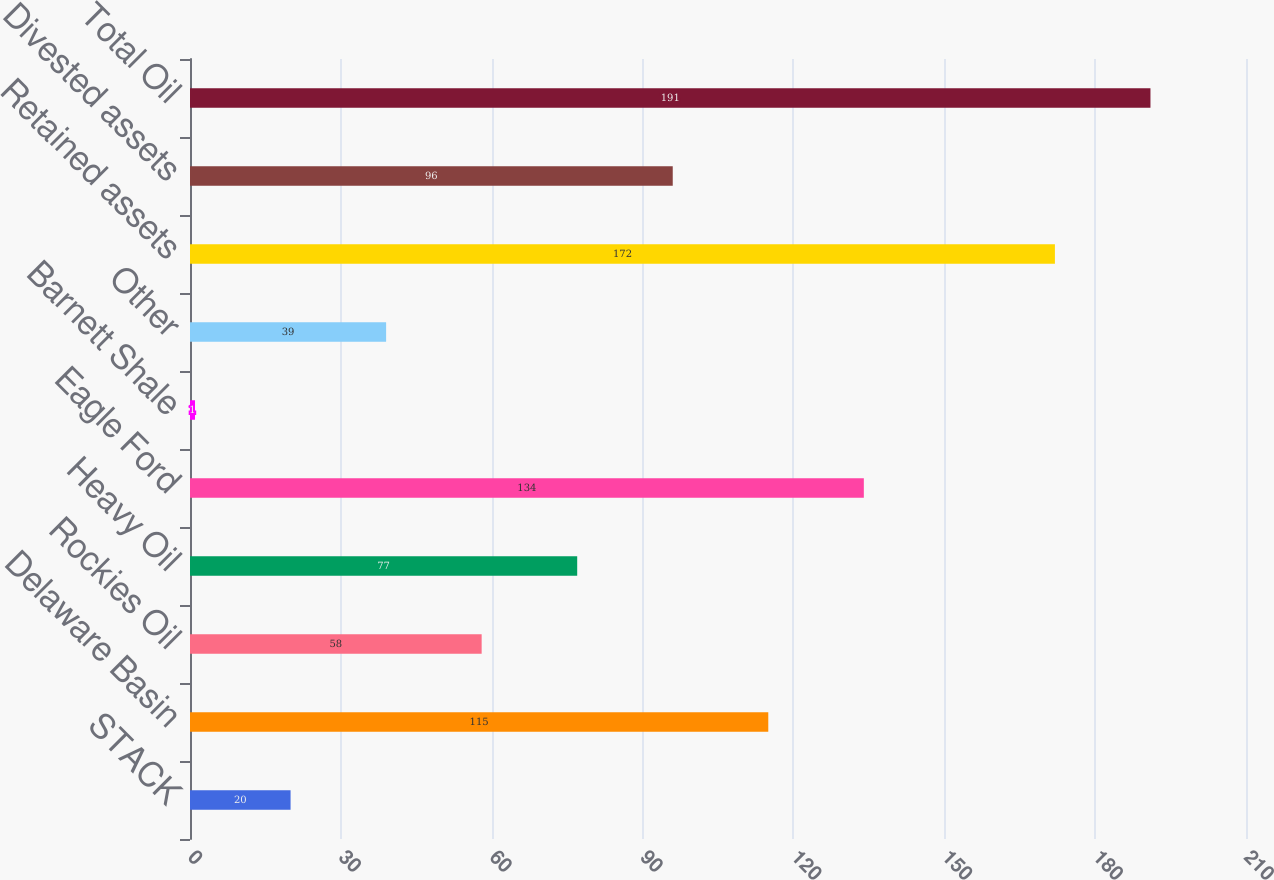Convert chart. <chart><loc_0><loc_0><loc_500><loc_500><bar_chart><fcel>STACK<fcel>Delaware Basin<fcel>Rockies Oil<fcel>Heavy Oil<fcel>Eagle Ford<fcel>Barnett Shale<fcel>Other<fcel>Retained assets<fcel>Divested assets<fcel>Total Oil<nl><fcel>20<fcel>115<fcel>58<fcel>77<fcel>134<fcel>1<fcel>39<fcel>172<fcel>96<fcel>191<nl></chart> 